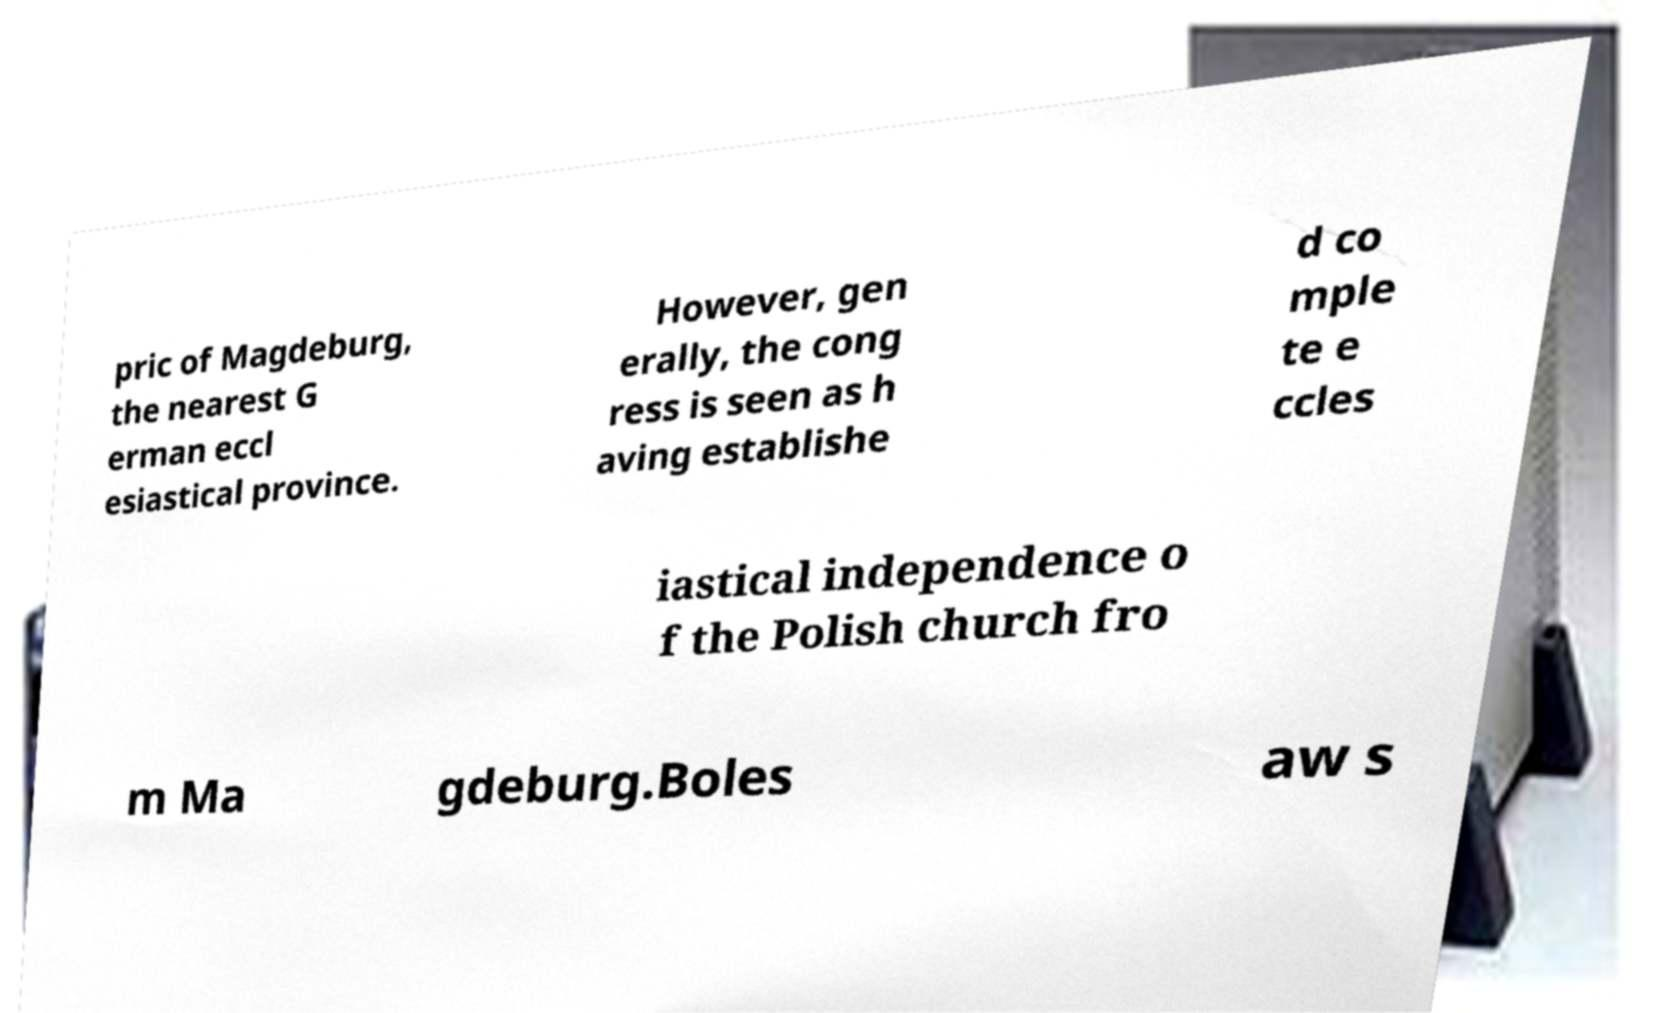Can you accurately transcribe the text from the provided image for me? pric of Magdeburg, the nearest G erman eccl esiastical province. However, gen erally, the cong ress is seen as h aving establishe d co mple te e ccles iastical independence o f the Polish church fro m Ma gdeburg.Boles aw s 